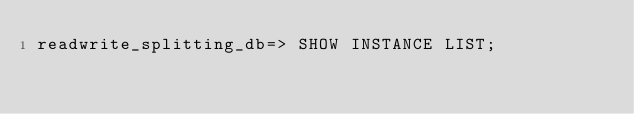Convert code to text. <code><loc_0><loc_0><loc_500><loc_500><_SQL_>readwrite_splitting_db=> SHOW INSTANCE LIST;
</code> 